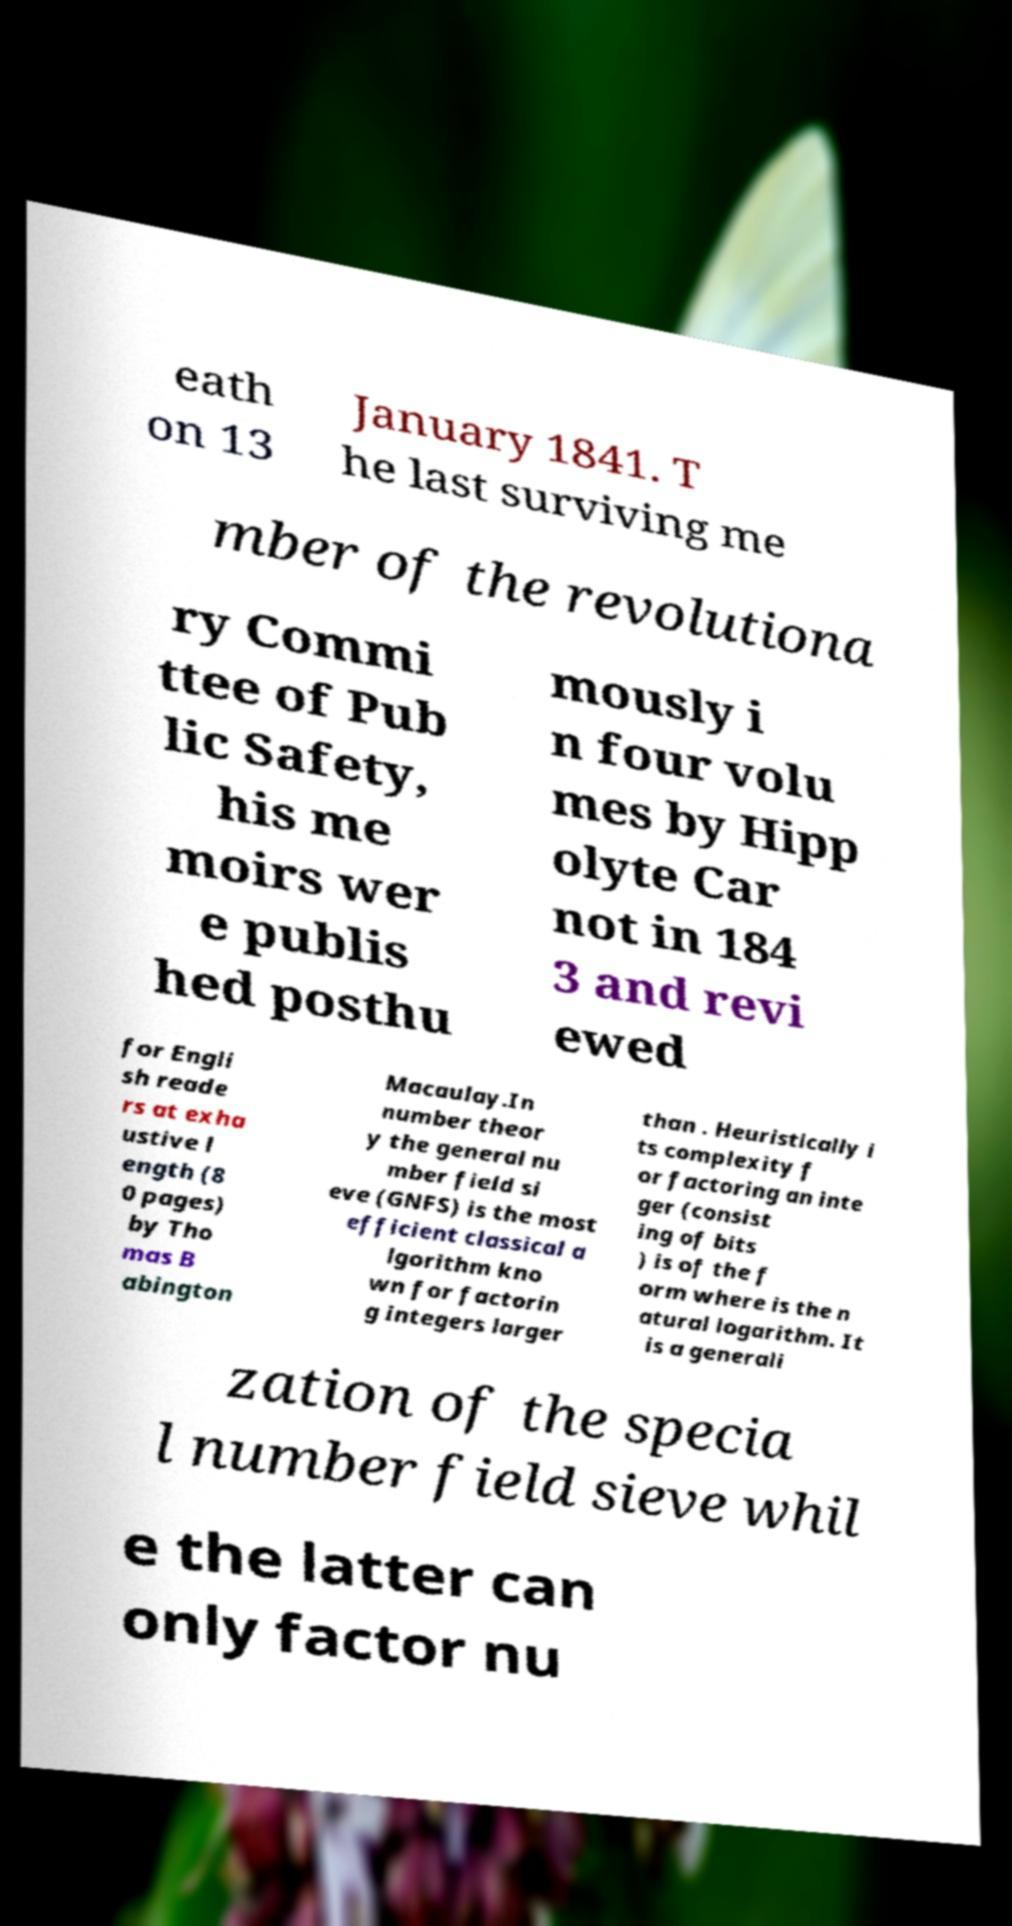What messages or text are displayed in this image? I need them in a readable, typed format. eath on 13 January 1841. T he last surviving me mber of the revolutiona ry Commi ttee of Pub lic Safety, his me moirs wer e publis hed posthu mously i n four volu mes by Hipp olyte Car not in 184 3 and revi ewed for Engli sh reade rs at exha ustive l ength (8 0 pages) by Tho mas B abington Macaulay.In number theor y the general nu mber field si eve (GNFS) is the most efficient classical a lgorithm kno wn for factorin g integers larger than . Heuristically i ts complexity f or factoring an inte ger (consist ing of bits ) is of the f orm where is the n atural logarithm. It is a generali zation of the specia l number field sieve whil e the latter can only factor nu 